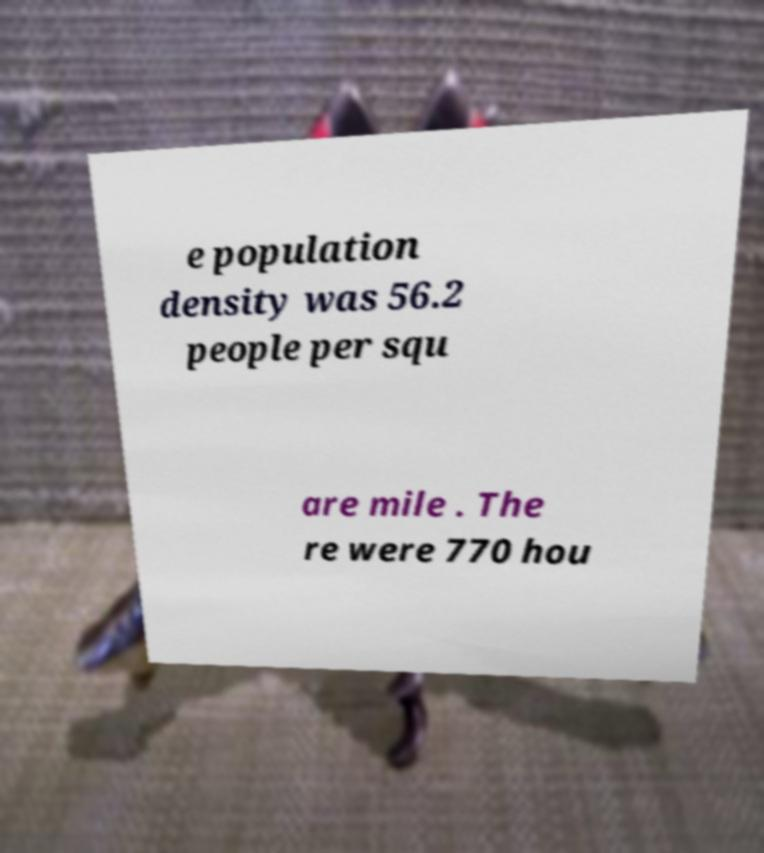I need the written content from this picture converted into text. Can you do that? e population density was 56.2 people per squ are mile . The re were 770 hou 